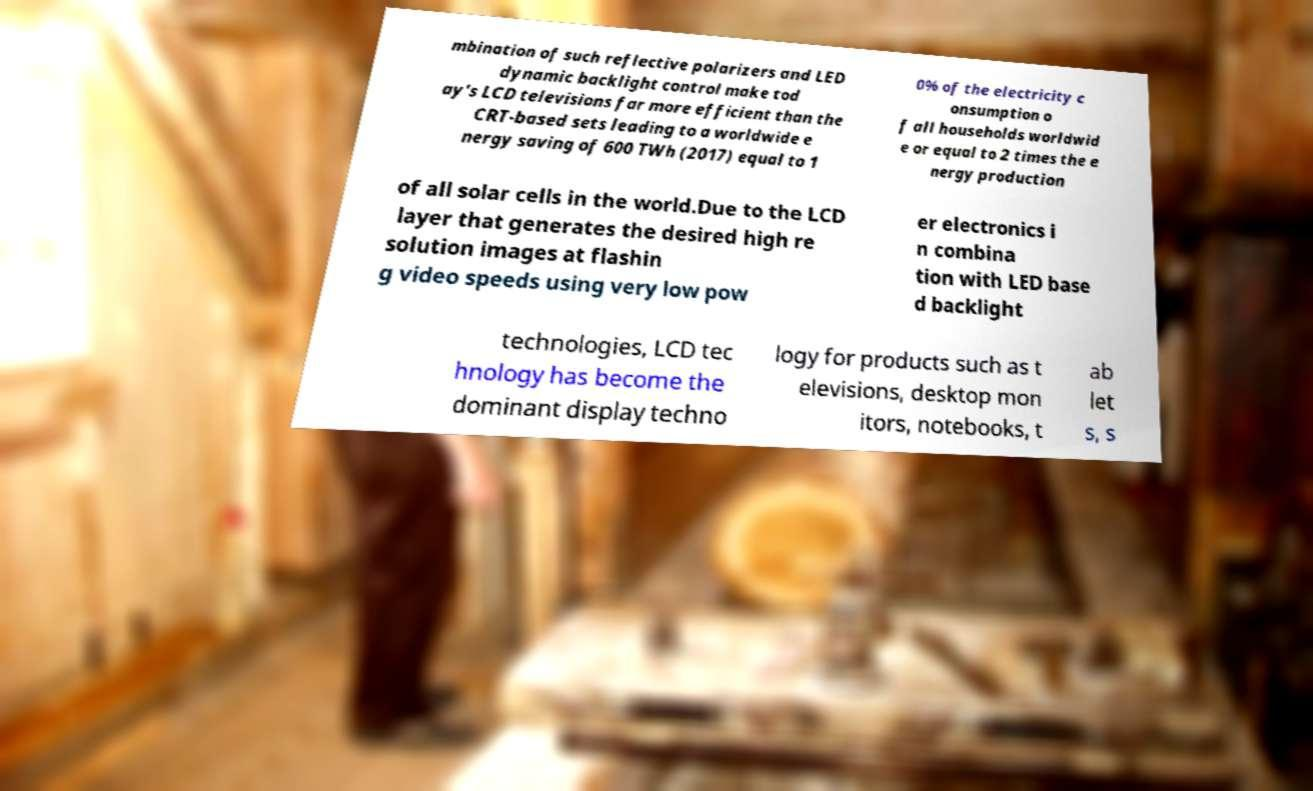For documentation purposes, I need the text within this image transcribed. Could you provide that? mbination of such reflective polarizers and LED dynamic backlight control make tod ay's LCD televisions far more efficient than the CRT-based sets leading to a worldwide e nergy saving of 600 TWh (2017) equal to 1 0% of the electricity c onsumption o f all households worldwid e or equal to 2 times the e nergy production of all solar cells in the world.Due to the LCD layer that generates the desired high re solution images at flashin g video speeds using very low pow er electronics i n combina tion with LED base d backlight technologies, LCD tec hnology has become the dominant display techno logy for products such as t elevisions, desktop mon itors, notebooks, t ab let s, s 